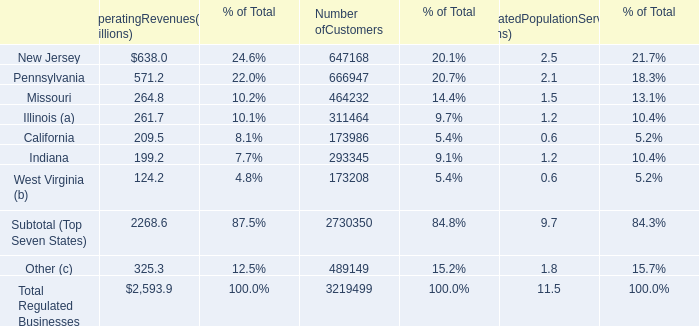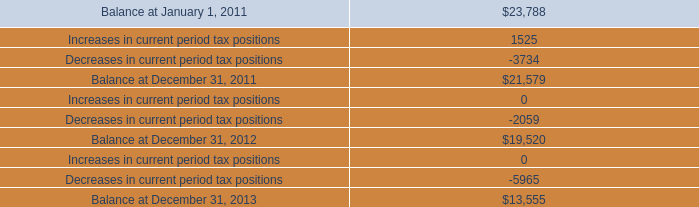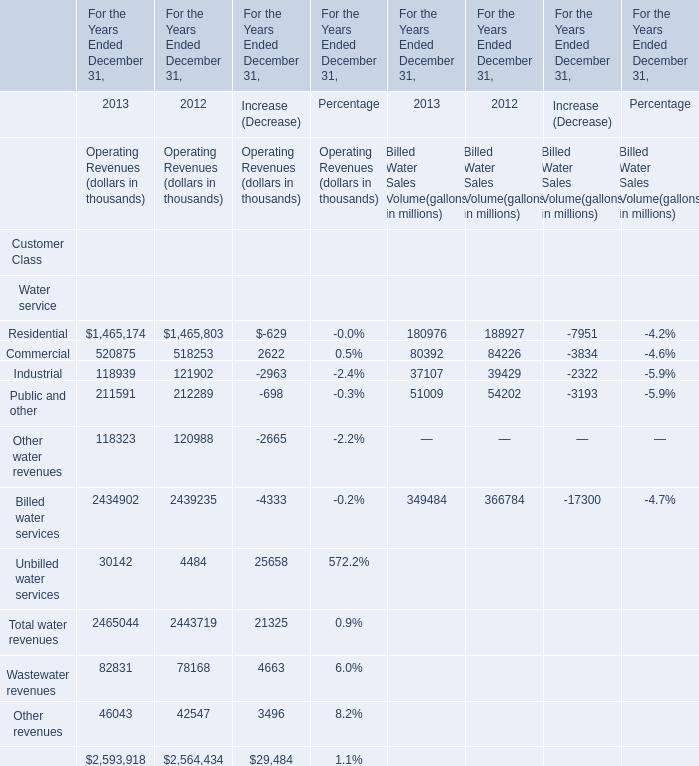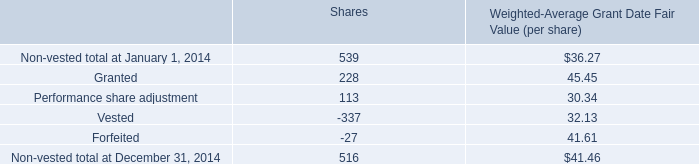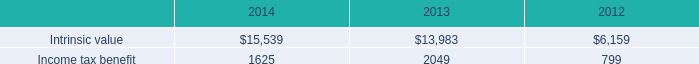what's the total amount of Intrinsic value of 2013, and Decreases in current period tax positions ? 
Computations: (13983.0 + 3734.0)
Answer: 17717.0. 